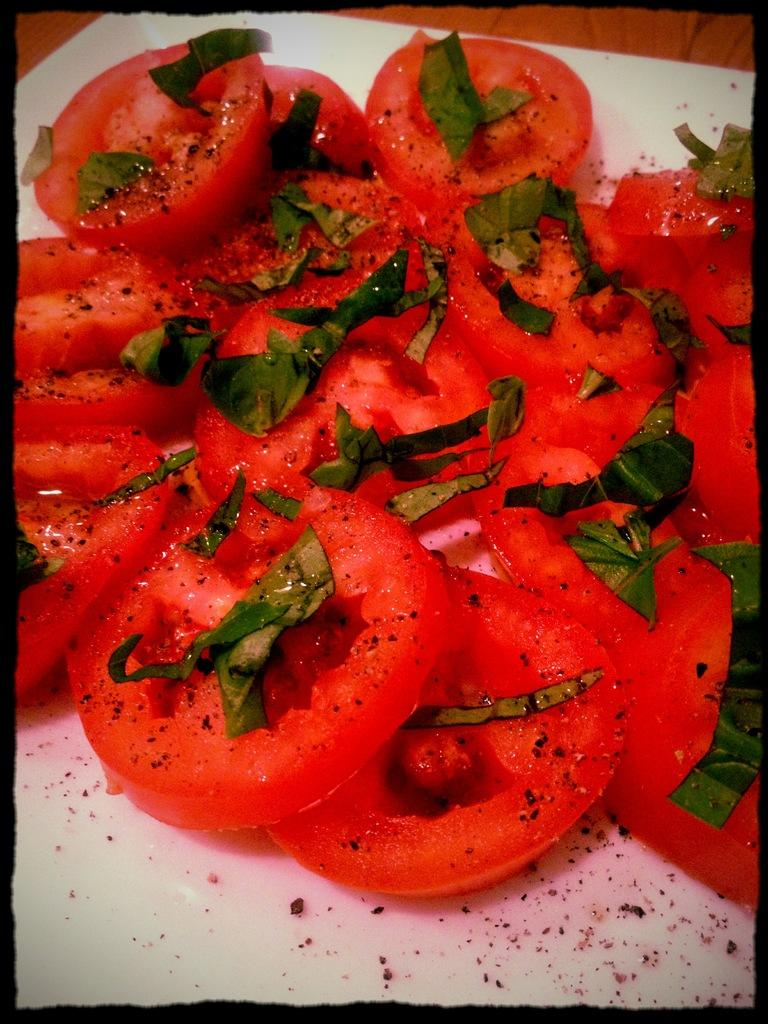What object is present in the image that might be used for serving or holding food? There is a plate in the image. What is on the plate? There is food on the plate. How are the plate and the food depicted in the image? The plate and the food are truncated. What type of chalk is being used to draw on the plate in the image? There is no chalk present in the image, and the plate and food are truncated, so it is not possible to see any drawings or markings. 